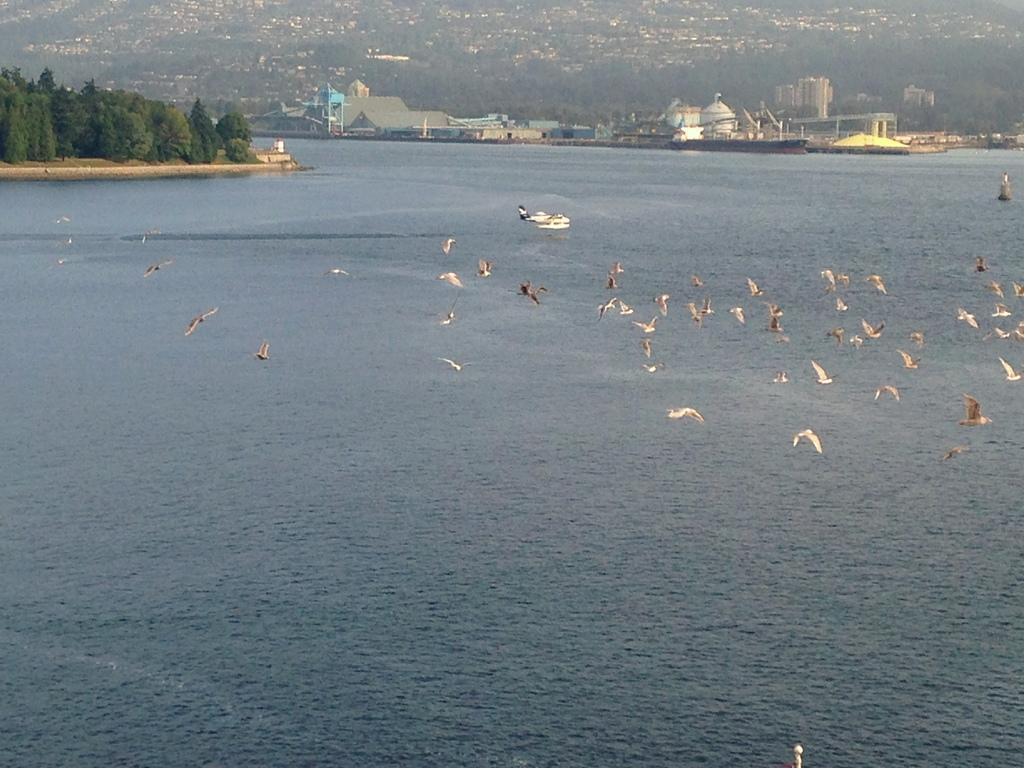Describe this image in one or two sentences. In this image we can see a group of birds flying in the sky. In the center of the image we can see a boat in the water. On the left side of the image we can see a group of trees. In the background, we can see some buildings, containers and some poles. 